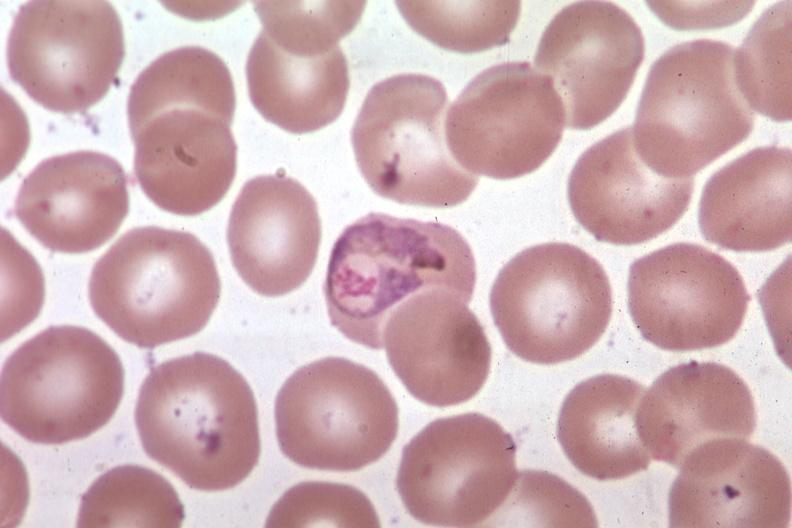does this image show oil wrights excellent?
Answer the question using a single word or phrase. Yes 